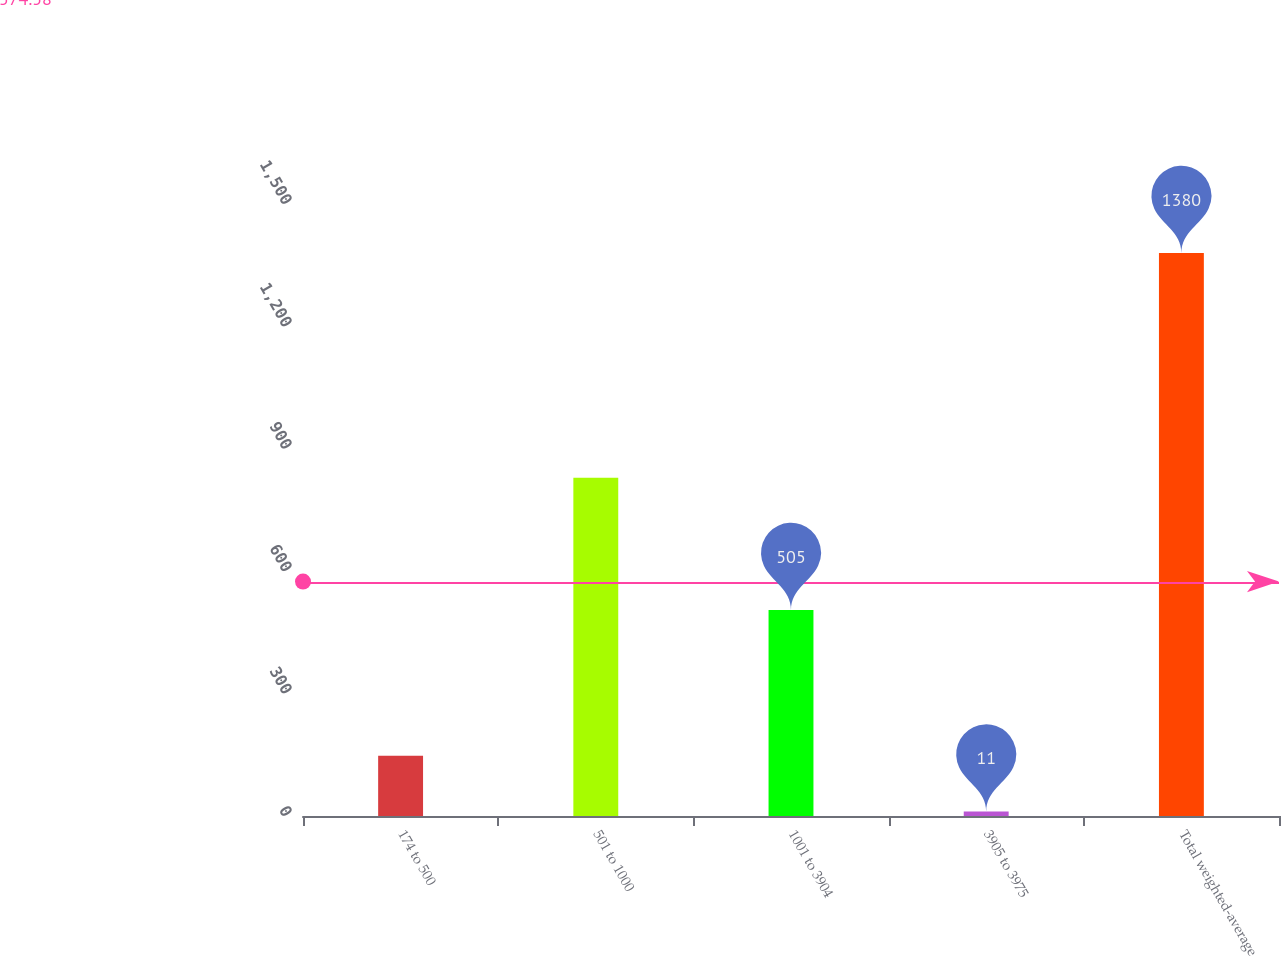Convert chart to OTSL. <chart><loc_0><loc_0><loc_500><loc_500><bar_chart><fcel>174 to 500<fcel>501 to 1000<fcel>1001 to 3904<fcel>3905 to 3975<fcel>Total weighted-average<nl><fcel>147.9<fcel>829<fcel>505<fcel>11<fcel>1380<nl></chart> 